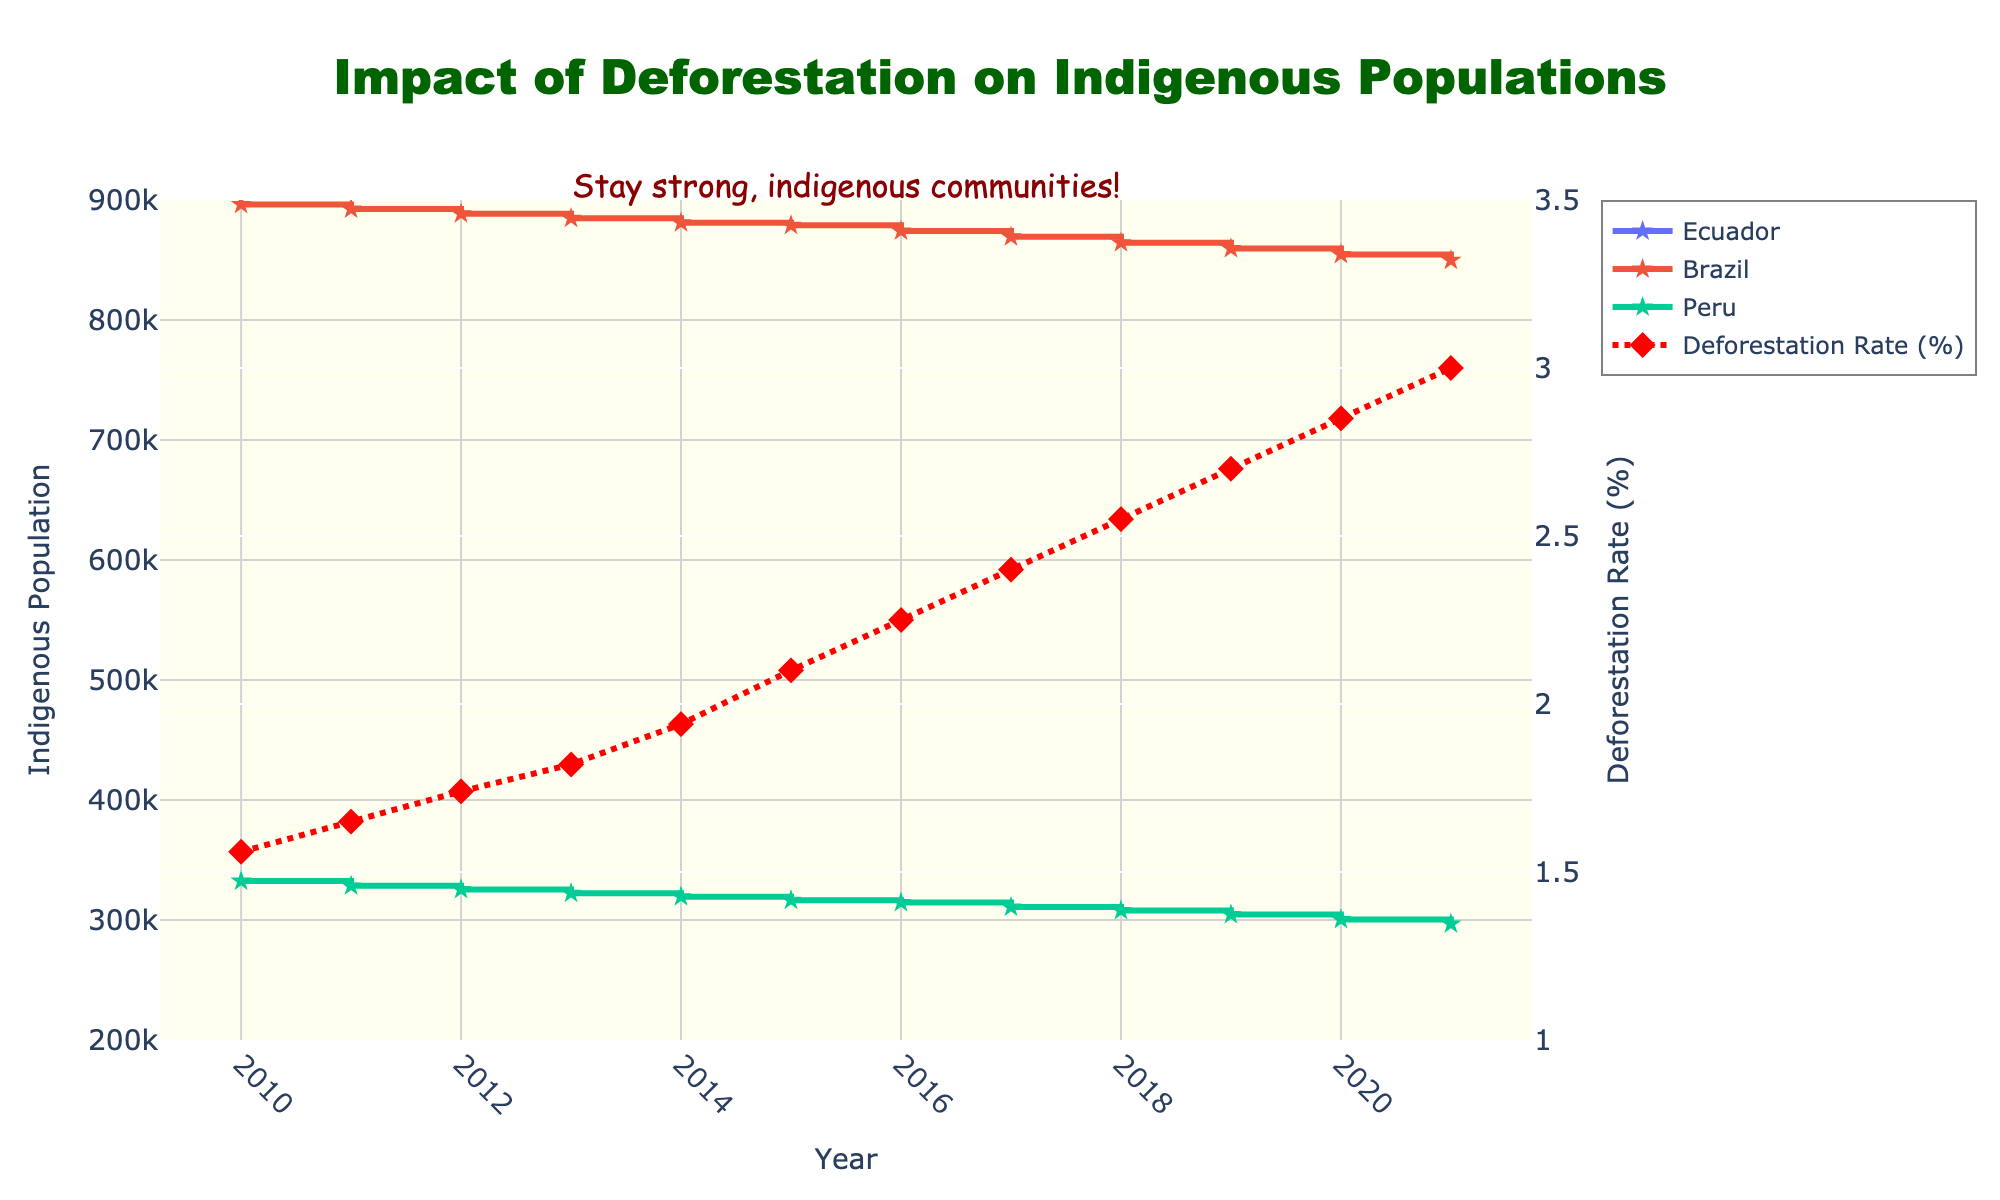What is the title of the figure? The title of the figure is displayed at the top and is written in large, bold font.
Answer: Impact of Deforestation on Indigenous Populations What years are covered in the figure's data? The x-axis represents the years covered in the figure, starting from the left and ending on the right.
Answer: 2010 to 2021 Which country had the highest indigenous population in 2010? From the three indigenous population lines, locate the highest point among Ecuador, Brazil, and Peru for the year 2010 on the x-axis.
Answer: Brazil How does the deforestation rate in 2015 compare to 2010? Locate the deforestation rate data points for 2010 and 2015 on the red dashed line, and compare their y-values.
Answer: It increased from 1.56% to 2.10% What trend is observed in the indigenous population of Peru from 2010 to 2021? Follow the line representing Peru and observe how it changes from 2010 to 2021.
Answer: It consistently decreases What is the approximate population decrease for indigenous Ecuadorians from 2010 to 2021? Subtract the population of indigenous Ecuadorians in 2021 from that in 2010, which can be found by referring to the respective y-values.
Answer: 11,100 Which year had the steepest increase in the deforestation rate? Look for the year with the largest vertical jump in the red dashed line representing deforestation rates.
Answer: 2014 to 2015 Compare the indigenous population trends in Brazil and Ecuador between 2015 and 2020. Examine the lines representing Brazil and Ecuador, comparing their y-values from 2015 to 2020.
Answer: Both decreased, but Brazil's decline was less steep By how much did the deforestation rate change from 2010 to 2021? Calculate the difference by subtracting the deforestation rate in 2010 from that in 2021.
Answer: 1.44% Which country saw the smallest reduction in indigenous population over the years in the figure? Compare the reduction in y-values of the indigenous population lines for all three countries from 2010 to 2021.
Answer: Brazil 